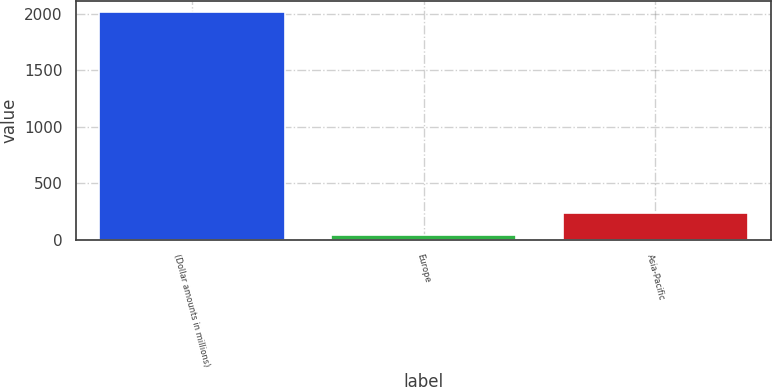<chart> <loc_0><loc_0><loc_500><loc_500><bar_chart><fcel>(Dollar amounts in millions)<fcel>Europe<fcel>Asia-Pacific<nl><fcel>2010<fcel>42<fcel>238.8<nl></chart> 